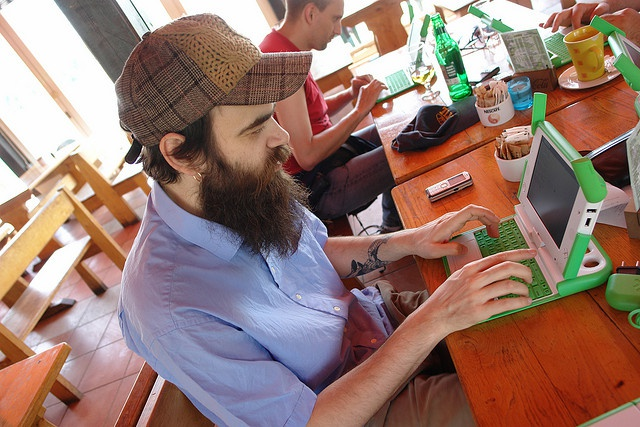Describe the objects in this image and their specific colors. I can see people in white, brown, gray, and maroon tones, dining table in white, brown, maroon, and darkgray tones, dining table in white, brown, black, and maroon tones, bench in white, brown, and tan tones, and people in white, black, brown, and maroon tones in this image. 